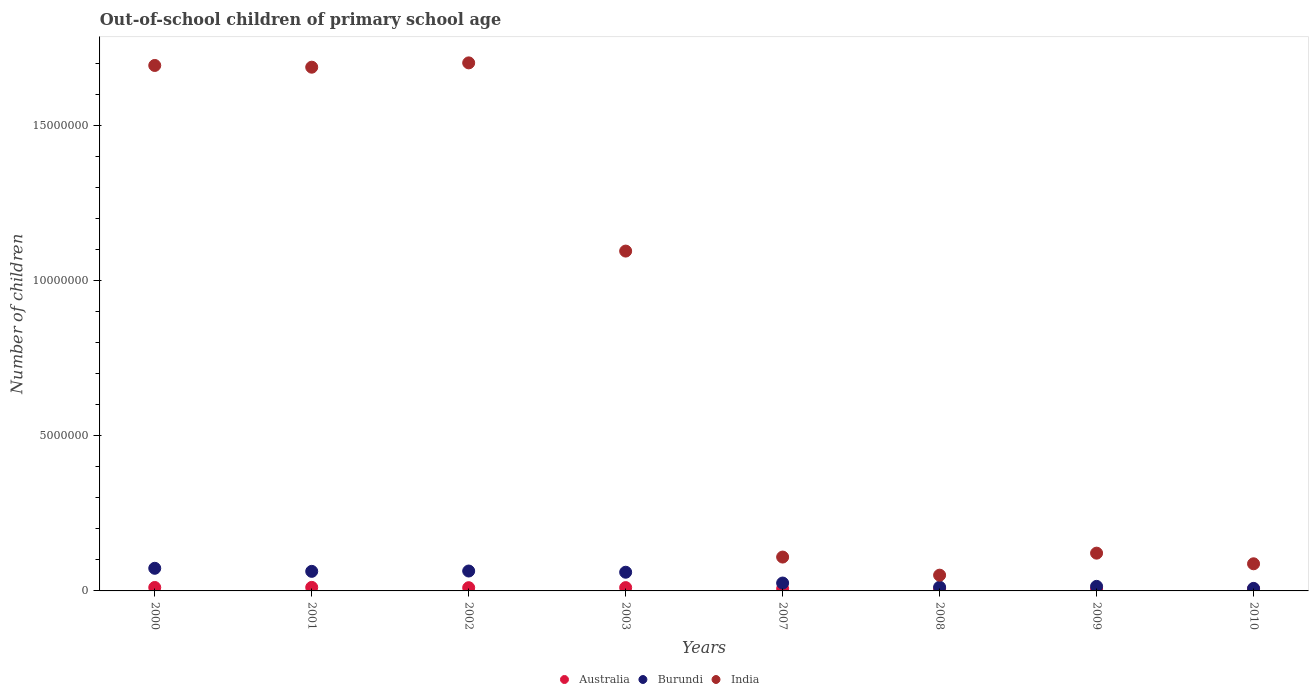What is the number of out-of-school children in Australia in 2001?
Ensure brevity in your answer.  1.14e+05. Across all years, what is the maximum number of out-of-school children in India?
Offer a very short reply. 1.70e+07. Across all years, what is the minimum number of out-of-school children in Burundi?
Ensure brevity in your answer.  8.12e+04. In which year was the number of out-of-school children in India maximum?
Offer a terse response. 2002. What is the total number of out-of-school children in Australia in the graph?
Your answer should be very brief. 7.07e+05. What is the difference between the number of out-of-school children in India in 2002 and that in 2007?
Provide a short and direct response. 1.59e+07. What is the difference between the number of out-of-school children in India in 2003 and the number of out-of-school children in Burundi in 2010?
Offer a very short reply. 1.09e+07. What is the average number of out-of-school children in India per year?
Ensure brevity in your answer.  8.19e+06. In the year 2000, what is the difference between the number of out-of-school children in Burundi and number of out-of-school children in Australia?
Offer a terse response. 6.19e+05. In how many years, is the number of out-of-school children in Australia greater than 1000000?
Keep it short and to the point. 0. What is the ratio of the number of out-of-school children in Burundi in 2002 to that in 2008?
Make the answer very short. 5.31. Is the number of out-of-school children in Burundi in 2000 less than that in 2002?
Make the answer very short. No. Is the difference between the number of out-of-school children in Burundi in 2009 and 2010 greater than the difference between the number of out-of-school children in Australia in 2009 and 2010?
Provide a short and direct response. Yes. What is the difference between the highest and the second highest number of out-of-school children in Burundi?
Keep it short and to the point. 8.79e+04. What is the difference between the highest and the lowest number of out-of-school children in India?
Your answer should be compact. 1.65e+07. Is the sum of the number of out-of-school children in Australia in 2003 and 2007 greater than the maximum number of out-of-school children in Burundi across all years?
Offer a very short reply. No. Is it the case that in every year, the sum of the number of out-of-school children in India and number of out-of-school children in Burundi  is greater than the number of out-of-school children in Australia?
Your response must be concise. Yes. What is the difference between two consecutive major ticks on the Y-axis?
Offer a terse response. 5.00e+06. Are the values on the major ticks of Y-axis written in scientific E-notation?
Give a very brief answer. No. Does the graph contain grids?
Ensure brevity in your answer.  No. What is the title of the graph?
Your answer should be compact. Out-of-school children of primary school age. Does "Philippines" appear as one of the legend labels in the graph?
Your answer should be very brief. No. What is the label or title of the Y-axis?
Your answer should be very brief. Number of children. What is the Number of children of Australia in 2000?
Offer a very short reply. 1.11e+05. What is the Number of children of Burundi in 2000?
Provide a short and direct response. 7.30e+05. What is the Number of children of India in 2000?
Keep it short and to the point. 1.69e+07. What is the Number of children of Australia in 2001?
Ensure brevity in your answer.  1.14e+05. What is the Number of children in Burundi in 2001?
Your response must be concise. 6.31e+05. What is the Number of children of India in 2001?
Your answer should be compact. 1.69e+07. What is the Number of children of Australia in 2002?
Keep it short and to the point. 1.04e+05. What is the Number of children of Burundi in 2002?
Offer a terse response. 6.42e+05. What is the Number of children in India in 2002?
Give a very brief answer. 1.70e+07. What is the Number of children in Australia in 2003?
Provide a succinct answer. 1.07e+05. What is the Number of children of Burundi in 2003?
Make the answer very short. 6.03e+05. What is the Number of children in India in 2003?
Provide a succinct answer. 1.10e+07. What is the Number of children of Australia in 2007?
Give a very brief answer. 7.13e+04. What is the Number of children of Burundi in 2007?
Offer a very short reply. 2.54e+05. What is the Number of children of India in 2007?
Provide a succinct answer. 1.09e+06. What is the Number of children in Australia in 2008?
Offer a very short reply. 6.86e+04. What is the Number of children in Burundi in 2008?
Your response must be concise. 1.21e+05. What is the Number of children of India in 2008?
Provide a short and direct response. 5.08e+05. What is the Number of children of Australia in 2009?
Ensure brevity in your answer.  6.49e+04. What is the Number of children of Burundi in 2009?
Offer a terse response. 1.47e+05. What is the Number of children in India in 2009?
Make the answer very short. 1.22e+06. What is the Number of children in Australia in 2010?
Your answer should be compact. 6.55e+04. What is the Number of children in Burundi in 2010?
Make the answer very short. 8.12e+04. What is the Number of children of India in 2010?
Keep it short and to the point. 8.75e+05. Across all years, what is the maximum Number of children of Australia?
Ensure brevity in your answer.  1.14e+05. Across all years, what is the maximum Number of children in Burundi?
Make the answer very short. 7.30e+05. Across all years, what is the maximum Number of children in India?
Make the answer very short. 1.70e+07. Across all years, what is the minimum Number of children in Australia?
Offer a very short reply. 6.49e+04. Across all years, what is the minimum Number of children of Burundi?
Ensure brevity in your answer.  8.12e+04. Across all years, what is the minimum Number of children of India?
Give a very brief answer. 5.08e+05. What is the total Number of children of Australia in the graph?
Your response must be concise. 7.07e+05. What is the total Number of children in Burundi in the graph?
Provide a succinct answer. 3.21e+06. What is the total Number of children in India in the graph?
Offer a very short reply. 6.55e+07. What is the difference between the Number of children in Australia in 2000 and that in 2001?
Your answer should be very brief. -3166. What is the difference between the Number of children in Burundi in 2000 and that in 2001?
Provide a short and direct response. 9.89e+04. What is the difference between the Number of children in India in 2000 and that in 2001?
Your answer should be compact. 5.58e+04. What is the difference between the Number of children of Australia in 2000 and that in 2002?
Offer a terse response. 6688. What is the difference between the Number of children of Burundi in 2000 and that in 2002?
Your answer should be compact. 8.79e+04. What is the difference between the Number of children in India in 2000 and that in 2002?
Your answer should be very brief. -8.34e+04. What is the difference between the Number of children in Australia in 2000 and that in 2003?
Offer a terse response. 4293. What is the difference between the Number of children in Burundi in 2000 and that in 2003?
Ensure brevity in your answer.  1.27e+05. What is the difference between the Number of children of India in 2000 and that in 2003?
Provide a short and direct response. 5.99e+06. What is the difference between the Number of children in Australia in 2000 and that in 2007?
Your answer should be very brief. 3.97e+04. What is the difference between the Number of children in Burundi in 2000 and that in 2007?
Offer a terse response. 4.76e+05. What is the difference between the Number of children in India in 2000 and that in 2007?
Give a very brief answer. 1.59e+07. What is the difference between the Number of children of Australia in 2000 and that in 2008?
Offer a very short reply. 4.24e+04. What is the difference between the Number of children of Burundi in 2000 and that in 2008?
Offer a terse response. 6.09e+05. What is the difference between the Number of children in India in 2000 and that in 2008?
Provide a succinct answer. 1.64e+07. What is the difference between the Number of children in Australia in 2000 and that in 2009?
Ensure brevity in your answer.  4.61e+04. What is the difference between the Number of children of Burundi in 2000 and that in 2009?
Give a very brief answer. 5.83e+05. What is the difference between the Number of children of India in 2000 and that in 2009?
Give a very brief answer. 1.57e+07. What is the difference between the Number of children in Australia in 2000 and that in 2010?
Your answer should be very brief. 4.55e+04. What is the difference between the Number of children of Burundi in 2000 and that in 2010?
Make the answer very short. 6.49e+05. What is the difference between the Number of children in India in 2000 and that in 2010?
Keep it short and to the point. 1.61e+07. What is the difference between the Number of children of Australia in 2001 and that in 2002?
Your answer should be very brief. 9854. What is the difference between the Number of children in Burundi in 2001 and that in 2002?
Keep it short and to the point. -1.10e+04. What is the difference between the Number of children of India in 2001 and that in 2002?
Ensure brevity in your answer.  -1.39e+05. What is the difference between the Number of children in Australia in 2001 and that in 2003?
Ensure brevity in your answer.  7459. What is the difference between the Number of children of Burundi in 2001 and that in 2003?
Keep it short and to the point. 2.81e+04. What is the difference between the Number of children in India in 2001 and that in 2003?
Make the answer very short. 5.93e+06. What is the difference between the Number of children in Australia in 2001 and that in 2007?
Keep it short and to the point. 4.29e+04. What is the difference between the Number of children of Burundi in 2001 and that in 2007?
Provide a short and direct response. 3.77e+05. What is the difference between the Number of children in India in 2001 and that in 2007?
Your answer should be compact. 1.58e+07. What is the difference between the Number of children in Australia in 2001 and that in 2008?
Offer a very short reply. 4.55e+04. What is the difference between the Number of children in Burundi in 2001 and that in 2008?
Make the answer very short. 5.10e+05. What is the difference between the Number of children of India in 2001 and that in 2008?
Your answer should be very brief. 1.64e+07. What is the difference between the Number of children of Australia in 2001 and that in 2009?
Provide a short and direct response. 4.93e+04. What is the difference between the Number of children in Burundi in 2001 and that in 2009?
Offer a very short reply. 4.84e+05. What is the difference between the Number of children of India in 2001 and that in 2009?
Offer a terse response. 1.57e+07. What is the difference between the Number of children of Australia in 2001 and that in 2010?
Your response must be concise. 4.87e+04. What is the difference between the Number of children in Burundi in 2001 and that in 2010?
Ensure brevity in your answer.  5.50e+05. What is the difference between the Number of children of India in 2001 and that in 2010?
Make the answer very short. 1.60e+07. What is the difference between the Number of children in Australia in 2002 and that in 2003?
Your response must be concise. -2395. What is the difference between the Number of children of Burundi in 2002 and that in 2003?
Your answer should be compact. 3.91e+04. What is the difference between the Number of children of India in 2002 and that in 2003?
Make the answer very short. 6.07e+06. What is the difference between the Number of children in Australia in 2002 and that in 2007?
Offer a very short reply. 3.30e+04. What is the difference between the Number of children of Burundi in 2002 and that in 2007?
Give a very brief answer. 3.88e+05. What is the difference between the Number of children of India in 2002 and that in 2007?
Provide a short and direct response. 1.59e+07. What is the difference between the Number of children in Australia in 2002 and that in 2008?
Keep it short and to the point. 3.57e+04. What is the difference between the Number of children of Burundi in 2002 and that in 2008?
Your answer should be compact. 5.21e+05. What is the difference between the Number of children of India in 2002 and that in 2008?
Offer a terse response. 1.65e+07. What is the difference between the Number of children of Australia in 2002 and that in 2009?
Ensure brevity in your answer.  3.94e+04. What is the difference between the Number of children in Burundi in 2002 and that in 2009?
Your answer should be very brief. 4.95e+05. What is the difference between the Number of children of India in 2002 and that in 2009?
Your answer should be very brief. 1.58e+07. What is the difference between the Number of children of Australia in 2002 and that in 2010?
Ensure brevity in your answer.  3.88e+04. What is the difference between the Number of children in Burundi in 2002 and that in 2010?
Your response must be concise. 5.61e+05. What is the difference between the Number of children of India in 2002 and that in 2010?
Provide a succinct answer. 1.62e+07. What is the difference between the Number of children in Australia in 2003 and that in 2007?
Ensure brevity in your answer.  3.54e+04. What is the difference between the Number of children of Burundi in 2003 and that in 2007?
Your response must be concise. 3.49e+05. What is the difference between the Number of children in India in 2003 and that in 2007?
Offer a terse response. 9.87e+06. What is the difference between the Number of children of Australia in 2003 and that in 2008?
Offer a terse response. 3.81e+04. What is the difference between the Number of children of Burundi in 2003 and that in 2008?
Ensure brevity in your answer.  4.82e+05. What is the difference between the Number of children in India in 2003 and that in 2008?
Provide a succinct answer. 1.05e+07. What is the difference between the Number of children of Australia in 2003 and that in 2009?
Provide a short and direct response. 4.18e+04. What is the difference between the Number of children of Burundi in 2003 and that in 2009?
Your answer should be very brief. 4.56e+05. What is the difference between the Number of children of India in 2003 and that in 2009?
Your answer should be very brief. 9.74e+06. What is the difference between the Number of children in Australia in 2003 and that in 2010?
Make the answer very short. 4.12e+04. What is the difference between the Number of children in Burundi in 2003 and that in 2010?
Your answer should be very brief. 5.22e+05. What is the difference between the Number of children of India in 2003 and that in 2010?
Offer a terse response. 1.01e+07. What is the difference between the Number of children in Australia in 2007 and that in 2008?
Provide a succinct answer. 2645. What is the difference between the Number of children of Burundi in 2007 and that in 2008?
Give a very brief answer. 1.33e+05. What is the difference between the Number of children of India in 2007 and that in 2008?
Your answer should be compact. 5.84e+05. What is the difference between the Number of children in Australia in 2007 and that in 2009?
Provide a short and direct response. 6358. What is the difference between the Number of children in Burundi in 2007 and that in 2009?
Provide a succinct answer. 1.07e+05. What is the difference between the Number of children in India in 2007 and that in 2009?
Your answer should be compact. -1.26e+05. What is the difference between the Number of children in Australia in 2007 and that in 2010?
Your response must be concise. 5799. What is the difference between the Number of children in Burundi in 2007 and that in 2010?
Provide a short and direct response. 1.73e+05. What is the difference between the Number of children of India in 2007 and that in 2010?
Give a very brief answer. 2.17e+05. What is the difference between the Number of children in Australia in 2008 and that in 2009?
Give a very brief answer. 3713. What is the difference between the Number of children of Burundi in 2008 and that in 2009?
Your answer should be compact. -2.60e+04. What is the difference between the Number of children in India in 2008 and that in 2009?
Keep it short and to the point. -7.10e+05. What is the difference between the Number of children of Australia in 2008 and that in 2010?
Make the answer very short. 3154. What is the difference between the Number of children of Burundi in 2008 and that in 2010?
Provide a succinct answer. 3.97e+04. What is the difference between the Number of children in India in 2008 and that in 2010?
Your response must be concise. -3.67e+05. What is the difference between the Number of children in Australia in 2009 and that in 2010?
Provide a succinct answer. -559. What is the difference between the Number of children in Burundi in 2009 and that in 2010?
Keep it short and to the point. 6.57e+04. What is the difference between the Number of children in India in 2009 and that in 2010?
Make the answer very short. 3.43e+05. What is the difference between the Number of children of Australia in 2000 and the Number of children of Burundi in 2001?
Your answer should be compact. -5.20e+05. What is the difference between the Number of children of Australia in 2000 and the Number of children of India in 2001?
Your answer should be very brief. -1.68e+07. What is the difference between the Number of children in Burundi in 2000 and the Number of children in India in 2001?
Your answer should be very brief. -1.62e+07. What is the difference between the Number of children of Australia in 2000 and the Number of children of Burundi in 2002?
Make the answer very short. -5.31e+05. What is the difference between the Number of children in Australia in 2000 and the Number of children in India in 2002?
Give a very brief answer. -1.69e+07. What is the difference between the Number of children of Burundi in 2000 and the Number of children of India in 2002?
Make the answer very short. -1.63e+07. What is the difference between the Number of children in Australia in 2000 and the Number of children in Burundi in 2003?
Your response must be concise. -4.92e+05. What is the difference between the Number of children in Australia in 2000 and the Number of children in India in 2003?
Offer a terse response. -1.08e+07. What is the difference between the Number of children in Burundi in 2000 and the Number of children in India in 2003?
Provide a short and direct response. -1.02e+07. What is the difference between the Number of children of Australia in 2000 and the Number of children of Burundi in 2007?
Your answer should be compact. -1.43e+05. What is the difference between the Number of children of Australia in 2000 and the Number of children of India in 2007?
Your answer should be compact. -9.81e+05. What is the difference between the Number of children of Burundi in 2000 and the Number of children of India in 2007?
Provide a short and direct response. -3.62e+05. What is the difference between the Number of children in Australia in 2000 and the Number of children in Burundi in 2008?
Provide a succinct answer. -9778. What is the difference between the Number of children in Australia in 2000 and the Number of children in India in 2008?
Offer a very short reply. -3.97e+05. What is the difference between the Number of children of Burundi in 2000 and the Number of children of India in 2008?
Keep it short and to the point. 2.22e+05. What is the difference between the Number of children of Australia in 2000 and the Number of children of Burundi in 2009?
Ensure brevity in your answer.  -3.58e+04. What is the difference between the Number of children in Australia in 2000 and the Number of children in India in 2009?
Your answer should be very brief. -1.11e+06. What is the difference between the Number of children in Burundi in 2000 and the Number of children in India in 2009?
Offer a terse response. -4.89e+05. What is the difference between the Number of children of Australia in 2000 and the Number of children of Burundi in 2010?
Ensure brevity in your answer.  2.99e+04. What is the difference between the Number of children of Australia in 2000 and the Number of children of India in 2010?
Make the answer very short. -7.64e+05. What is the difference between the Number of children in Burundi in 2000 and the Number of children in India in 2010?
Provide a succinct answer. -1.45e+05. What is the difference between the Number of children of Australia in 2001 and the Number of children of Burundi in 2002?
Provide a short and direct response. -5.28e+05. What is the difference between the Number of children of Australia in 2001 and the Number of children of India in 2002?
Your response must be concise. -1.69e+07. What is the difference between the Number of children in Burundi in 2001 and the Number of children in India in 2002?
Provide a short and direct response. -1.64e+07. What is the difference between the Number of children of Australia in 2001 and the Number of children of Burundi in 2003?
Offer a very short reply. -4.89e+05. What is the difference between the Number of children of Australia in 2001 and the Number of children of India in 2003?
Provide a succinct answer. -1.08e+07. What is the difference between the Number of children in Burundi in 2001 and the Number of children in India in 2003?
Provide a succinct answer. -1.03e+07. What is the difference between the Number of children of Australia in 2001 and the Number of children of Burundi in 2007?
Give a very brief answer. -1.40e+05. What is the difference between the Number of children in Australia in 2001 and the Number of children in India in 2007?
Your response must be concise. -9.78e+05. What is the difference between the Number of children in Burundi in 2001 and the Number of children in India in 2007?
Offer a very short reply. -4.61e+05. What is the difference between the Number of children in Australia in 2001 and the Number of children in Burundi in 2008?
Offer a terse response. -6612. What is the difference between the Number of children in Australia in 2001 and the Number of children in India in 2008?
Your answer should be very brief. -3.94e+05. What is the difference between the Number of children in Burundi in 2001 and the Number of children in India in 2008?
Ensure brevity in your answer.  1.23e+05. What is the difference between the Number of children in Australia in 2001 and the Number of children in Burundi in 2009?
Your answer should be compact. -3.26e+04. What is the difference between the Number of children in Australia in 2001 and the Number of children in India in 2009?
Offer a terse response. -1.10e+06. What is the difference between the Number of children in Burundi in 2001 and the Number of children in India in 2009?
Your answer should be very brief. -5.87e+05. What is the difference between the Number of children of Australia in 2001 and the Number of children of Burundi in 2010?
Your answer should be very brief. 3.30e+04. What is the difference between the Number of children of Australia in 2001 and the Number of children of India in 2010?
Make the answer very short. -7.61e+05. What is the difference between the Number of children of Burundi in 2001 and the Number of children of India in 2010?
Offer a terse response. -2.44e+05. What is the difference between the Number of children of Australia in 2002 and the Number of children of Burundi in 2003?
Ensure brevity in your answer.  -4.99e+05. What is the difference between the Number of children of Australia in 2002 and the Number of children of India in 2003?
Your answer should be very brief. -1.09e+07. What is the difference between the Number of children of Burundi in 2002 and the Number of children of India in 2003?
Keep it short and to the point. -1.03e+07. What is the difference between the Number of children in Australia in 2002 and the Number of children in Burundi in 2007?
Your response must be concise. -1.50e+05. What is the difference between the Number of children of Australia in 2002 and the Number of children of India in 2007?
Your response must be concise. -9.88e+05. What is the difference between the Number of children in Burundi in 2002 and the Number of children in India in 2007?
Your response must be concise. -4.50e+05. What is the difference between the Number of children in Australia in 2002 and the Number of children in Burundi in 2008?
Make the answer very short. -1.65e+04. What is the difference between the Number of children of Australia in 2002 and the Number of children of India in 2008?
Provide a short and direct response. -4.04e+05. What is the difference between the Number of children in Burundi in 2002 and the Number of children in India in 2008?
Make the answer very short. 1.34e+05. What is the difference between the Number of children in Australia in 2002 and the Number of children in Burundi in 2009?
Provide a succinct answer. -4.25e+04. What is the difference between the Number of children in Australia in 2002 and the Number of children in India in 2009?
Provide a short and direct response. -1.11e+06. What is the difference between the Number of children in Burundi in 2002 and the Number of children in India in 2009?
Make the answer very short. -5.76e+05. What is the difference between the Number of children of Australia in 2002 and the Number of children of Burundi in 2010?
Ensure brevity in your answer.  2.32e+04. What is the difference between the Number of children in Australia in 2002 and the Number of children in India in 2010?
Your answer should be compact. -7.71e+05. What is the difference between the Number of children in Burundi in 2002 and the Number of children in India in 2010?
Make the answer very short. -2.33e+05. What is the difference between the Number of children of Australia in 2003 and the Number of children of Burundi in 2007?
Your answer should be compact. -1.47e+05. What is the difference between the Number of children of Australia in 2003 and the Number of children of India in 2007?
Provide a short and direct response. -9.85e+05. What is the difference between the Number of children in Burundi in 2003 and the Number of children in India in 2007?
Your answer should be very brief. -4.89e+05. What is the difference between the Number of children of Australia in 2003 and the Number of children of Burundi in 2008?
Provide a short and direct response. -1.41e+04. What is the difference between the Number of children of Australia in 2003 and the Number of children of India in 2008?
Keep it short and to the point. -4.01e+05. What is the difference between the Number of children in Burundi in 2003 and the Number of children in India in 2008?
Your response must be concise. 9.48e+04. What is the difference between the Number of children in Australia in 2003 and the Number of children in Burundi in 2009?
Ensure brevity in your answer.  -4.01e+04. What is the difference between the Number of children in Australia in 2003 and the Number of children in India in 2009?
Ensure brevity in your answer.  -1.11e+06. What is the difference between the Number of children in Burundi in 2003 and the Number of children in India in 2009?
Make the answer very short. -6.16e+05. What is the difference between the Number of children of Australia in 2003 and the Number of children of Burundi in 2010?
Your answer should be very brief. 2.56e+04. What is the difference between the Number of children of Australia in 2003 and the Number of children of India in 2010?
Your response must be concise. -7.68e+05. What is the difference between the Number of children of Burundi in 2003 and the Number of children of India in 2010?
Your answer should be compact. -2.72e+05. What is the difference between the Number of children in Australia in 2007 and the Number of children in Burundi in 2008?
Ensure brevity in your answer.  -4.95e+04. What is the difference between the Number of children in Australia in 2007 and the Number of children in India in 2008?
Make the answer very short. -4.37e+05. What is the difference between the Number of children of Burundi in 2007 and the Number of children of India in 2008?
Provide a succinct answer. -2.54e+05. What is the difference between the Number of children in Australia in 2007 and the Number of children in Burundi in 2009?
Your answer should be compact. -7.55e+04. What is the difference between the Number of children in Australia in 2007 and the Number of children in India in 2009?
Your response must be concise. -1.15e+06. What is the difference between the Number of children in Burundi in 2007 and the Number of children in India in 2009?
Your response must be concise. -9.64e+05. What is the difference between the Number of children in Australia in 2007 and the Number of children in Burundi in 2010?
Give a very brief answer. -9858. What is the difference between the Number of children of Australia in 2007 and the Number of children of India in 2010?
Your response must be concise. -8.04e+05. What is the difference between the Number of children in Burundi in 2007 and the Number of children in India in 2010?
Your response must be concise. -6.21e+05. What is the difference between the Number of children of Australia in 2008 and the Number of children of Burundi in 2009?
Provide a succinct answer. -7.82e+04. What is the difference between the Number of children in Australia in 2008 and the Number of children in India in 2009?
Offer a terse response. -1.15e+06. What is the difference between the Number of children of Burundi in 2008 and the Number of children of India in 2009?
Keep it short and to the point. -1.10e+06. What is the difference between the Number of children of Australia in 2008 and the Number of children of Burundi in 2010?
Give a very brief answer. -1.25e+04. What is the difference between the Number of children of Australia in 2008 and the Number of children of India in 2010?
Your answer should be compact. -8.06e+05. What is the difference between the Number of children in Burundi in 2008 and the Number of children in India in 2010?
Your answer should be very brief. -7.54e+05. What is the difference between the Number of children of Australia in 2009 and the Number of children of Burundi in 2010?
Keep it short and to the point. -1.62e+04. What is the difference between the Number of children of Australia in 2009 and the Number of children of India in 2010?
Provide a short and direct response. -8.10e+05. What is the difference between the Number of children in Burundi in 2009 and the Number of children in India in 2010?
Give a very brief answer. -7.28e+05. What is the average Number of children in Australia per year?
Offer a terse response. 8.83e+04. What is the average Number of children of Burundi per year?
Provide a succinct answer. 4.01e+05. What is the average Number of children in India per year?
Offer a terse response. 8.19e+06. In the year 2000, what is the difference between the Number of children in Australia and Number of children in Burundi?
Ensure brevity in your answer.  -6.19e+05. In the year 2000, what is the difference between the Number of children of Australia and Number of children of India?
Your response must be concise. -1.68e+07. In the year 2000, what is the difference between the Number of children in Burundi and Number of children in India?
Keep it short and to the point. -1.62e+07. In the year 2001, what is the difference between the Number of children of Australia and Number of children of Burundi?
Your response must be concise. -5.17e+05. In the year 2001, what is the difference between the Number of children in Australia and Number of children in India?
Provide a short and direct response. -1.68e+07. In the year 2001, what is the difference between the Number of children of Burundi and Number of children of India?
Give a very brief answer. -1.63e+07. In the year 2002, what is the difference between the Number of children of Australia and Number of children of Burundi?
Your response must be concise. -5.38e+05. In the year 2002, what is the difference between the Number of children in Australia and Number of children in India?
Your response must be concise. -1.69e+07. In the year 2002, what is the difference between the Number of children of Burundi and Number of children of India?
Keep it short and to the point. -1.64e+07. In the year 2003, what is the difference between the Number of children of Australia and Number of children of Burundi?
Ensure brevity in your answer.  -4.96e+05. In the year 2003, what is the difference between the Number of children of Australia and Number of children of India?
Offer a terse response. -1.09e+07. In the year 2003, what is the difference between the Number of children of Burundi and Number of children of India?
Your answer should be compact. -1.04e+07. In the year 2007, what is the difference between the Number of children of Australia and Number of children of Burundi?
Your response must be concise. -1.83e+05. In the year 2007, what is the difference between the Number of children in Australia and Number of children in India?
Keep it short and to the point. -1.02e+06. In the year 2007, what is the difference between the Number of children in Burundi and Number of children in India?
Provide a succinct answer. -8.38e+05. In the year 2008, what is the difference between the Number of children in Australia and Number of children in Burundi?
Offer a terse response. -5.22e+04. In the year 2008, what is the difference between the Number of children in Australia and Number of children in India?
Your answer should be compact. -4.39e+05. In the year 2008, what is the difference between the Number of children in Burundi and Number of children in India?
Your answer should be compact. -3.87e+05. In the year 2009, what is the difference between the Number of children of Australia and Number of children of Burundi?
Keep it short and to the point. -8.19e+04. In the year 2009, what is the difference between the Number of children in Australia and Number of children in India?
Give a very brief answer. -1.15e+06. In the year 2009, what is the difference between the Number of children in Burundi and Number of children in India?
Your answer should be compact. -1.07e+06. In the year 2010, what is the difference between the Number of children in Australia and Number of children in Burundi?
Your response must be concise. -1.57e+04. In the year 2010, what is the difference between the Number of children of Australia and Number of children of India?
Give a very brief answer. -8.10e+05. In the year 2010, what is the difference between the Number of children in Burundi and Number of children in India?
Your response must be concise. -7.94e+05. What is the ratio of the Number of children in Australia in 2000 to that in 2001?
Your response must be concise. 0.97. What is the ratio of the Number of children in Burundi in 2000 to that in 2001?
Your answer should be very brief. 1.16. What is the ratio of the Number of children of Australia in 2000 to that in 2002?
Ensure brevity in your answer.  1.06. What is the ratio of the Number of children of Burundi in 2000 to that in 2002?
Give a very brief answer. 1.14. What is the ratio of the Number of children of India in 2000 to that in 2002?
Ensure brevity in your answer.  1. What is the ratio of the Number of children in Australia in 2000 to that in 2003?
Offer a very short reply. 1.04. What is the ratio of the Number of children in Burundi in 2000 to that in 2003?
Make the answer very short. 1.21. What is the ratio of the Number of children of India in 2000 to that in 2003?
Offer a very short reply. 1.55. What is the ratio of the Number of children in Australia in 2000 to that in 2007?
Keep it short and to the point. 1.56. What is the ratio of the Number of children in Burundi in 2000 to that in 2007?
Provide a short and direct response. 2.87. What is the ratio of the Number of children in India in 2000 to that in 2007?
Keep it short and to the point. 15.52. What is the ratio of the Number of children of Australia in 2000 to that in 2008?
Your answer should be compact. 1.62. What is the ratio of the Number of children in Burundi in 2000 to that in 2008?
Your answer should be very brief. 6.04. What is the ratio of the Number of children in India in 2000 to that in 2008?
Ensure brevity in your answer.  33.35. What is the ratio of the Number of children in Australia in 2000 to that in 2009?
Your answer should be compact. 1.71. What is the ratio of the Number of children in Burundi in 2000 to that in 2009?
Offer a terse response. 4.97. What is the ratio of the Number of children of India in 2000 to that in 2009?
Your response must be concise. 13.91. What is the ratio of the Number of children of Australia in 2000 to that in 2010?
Provide a short and direct response. 1.7. What is the ratio of the Number of children of Burundi in 2000 to that in 2010?
Ensure brevity in your answer.  8.99. What is the ratio of the Number of children in India in 2000 to that in 2010?
Your response must be concise. 19.37. What is the ratio of the Number of children of Australia in 2001 to that in 2002?
Provide a short and direct response. 1.09. What is the ratio of the Number of children in Burundi in 2001 to that in 2002?
Give a very brief answer. 0.98. What is the ratio of the Number of children of India in 2001 to that in 2002?
Your answer should be compact. 0.99. What is the ratio of the Number of children in Australia in 2001 to that in 2003?
Your response must be concise. 1.07. What is the ratio of the Number of children of Burundi in 2001 to that in 2003?
Provide a short and direct response. 1.05. What is the ratio of the Number of children of India in 2001 to that in 2003?
Your response must be concise. 1.54. What is the ratio of the Number of children of Australia in 2001 to that in 2007?
Ensure brevity in your answer.  1.6. What is the ratio of the Number of children in Burundi in 2001 to that in 2007?
Offer a terse response. 2.48. What is the ratio of the Number of children in India in 2001 to that in 2007?
Offer a terse response. 15.47. What is the ratio of the Number of children of Australia in 2001 to that in 2008?
Offer a very short reply. 1.66. What is the ratio of the Number of children of Burundi in 2001 to that in 2008?
Ensure brevity in your answer.  5.22. What is the ratio of the Number of children of India in 2001 to that in 2008?
Keep it short and to the point. 33.24. What is the ratio of the Number of children of Australia in 2001 to that in 2009?
Give a very brief answer. 1.76. What is the ratio of the Number of children of Burundi in 2001 to that in 2009?
Keep it short and to the point. 4.3. What is the ratio of the Number of children of India in 2001 to that in 2009?
Provide a succinct answer. 13.86. What is the ratio of the Number of children of Australia in 2001 to that in 2010?
Keep it short and to the point. 1.74. What is the ratio of the Number of children of Burundi in 2001 to that in 2010?
Ensure brevity in your answer.  7.78. What is the ratio of the Number of children in India in 2001 to that in 2010?
Make the answer very short. 19.3. What is the ratio of the Number of children of Australia in 2002 to that in 2003?
Give a very brief answer. 0.98. What is the ratio of the Number of children in Burundi in 2002 to that in 2003?
Ensure brevity in your answer.  1.06. What is the ratio of the Number of children of India in 2002 to that in 2003?
Your answer should be very brief. 1.55. What is the ratio of the Number of children of Australia in 2002 to that in 2007?
Keep it short and to the point. 1.46. What is the ratio of the Number of children in Burundi in 2002 to that in 2007?
Your answer should be compact. 2.53. What is the ratio of the Number of children in India in 2002 to that in 2007?
Your answer should be compact. 15.6. What is the ratio of the Number of children in Australia in 2002 to that in 2008?
Provide a short and direct response. 1.52. What is the ratio of the Number of children in Burundi in 2002 to that in 2008?
Offer a very short reply. 5.31. What is the ratio of the Number of children of India in 2002 to that in 2008?
Offer a terse response. 33.52. What is the ratio of the Number of children in Australia in 2002 to that in 2009?
Offer a terse response. 1.61. What is the ratio of the Number of children of Burundi in 2002 to that in 2009?
Provide a short and direct response. 4.37. What is the ratio of the Number of children of India in 2002 to that in 2009?
Offer a terse response. 13.98. What is the ratio of the Number of children in Australia in 2002 to that in 2010?
Your response must be concise. 1.59. What is the ratio of the Number of children of Burundi in 2002 to that in 2010?
Give a very brief answer. 7.91. What is the ratio of the Number of children of India in 2002 to that in 2010?
Ensure brevity in your answer.  19.46. What is the ratio of the Number of children in Australia in 2003 to that in 2007?
Offer a terse response. 1.5. What is the ratio of the Number of children in Burundi in 2003 to that in 2007?
Provide a succinct answer. 2.37. What is the ratio of the Number of children of India in 2003 to that in 2007?
Keep it short and to the point. 10.04. What is the ratio of the Number of children of Australia in 2003 to that in 2008?
Offer a very short reply. 1.55. What is the ratio of the Number of children of Burundi in 2003 to that in 2008?
Your response must be concise. 4.99. What is the ratio of the Number of children in India in 2003 to that in 2008?
Provide a succinct answer. 21.57. What is the ratio of the Number of children in Australia in 2003 to that in 2009?
Make the answer very short. 1.64. What is the ratio of the Number of children of Burundi in 2003 to that in 2009?
Keep it short and to the point. 4.11. What is the ratio of the Number of children of India in 2003 to that in 2009?
Offer a very short reply. 9. What is the ratio of the Number of children in Australia in 2003 to that in 2010?
Offer a terse response. 1.63. What is the ratio of the Number of children in Burundi in 2003 to that in 2010?
Your response must be concise. 7.43. What is the ratio of the Number of children in India in 2003 to that in 2010?
Make the answer very short. 12.53. What is the ratio of the Number of children of Australia in 2007 to that in 2008?
Provide a succinct answer. 1.04. What is the ratio of the Number of children of Burundi in 2007 to that in 2008?
Offer a terse response. 2.1. What is the ratio of the Number of children of India in 2007 to that in 2008?
Your answer should be compact. 2.15. What is the ratio of the Number of children in Australia in 2007 to that in 2009?
Your response must be concise. 1.1. What is the ratio of the Number of children of Burundi in 2007 to that in 2009?
Your answer should be compact. 1.73. What is the ratio of the Number of children of India in 2007 to that in 2009?
Make the answer very short. 0.9. What is the ratio of the Number of children in Australia in 2007 to that in 2010?
Give a very brief answer. 1.09. What is the ratio of the Number of children of Burundi in 2007 to that in 2010?
Make the answer very short. 3.13. What is the ratio of the Number of children of India in 2007 to that in 2010?
Keep it short and to the point. 1.25. What is the ratio of the Number of children of Australia in 2008 to that in 2009?
Make the answer very short. 1.06. What is the ratio of the Number of children of Burundi in 2008 to that in 2009?
Ensure brevity in your answer.  0.82. What is the ratio of the Number of children in India in 2008 to that in 2009?
Your answer should be very brief. 0.42. What is the ratio of the Number of children of Australia in 2008 to that in 2010?
Your answer should be compact. 1.05. What is the ratio of the Number of children of Burundi in 2008 to that in 2010?
Offer a very short reply. 1.49. What is the ratio of the Number of children in India in 2008 to that in 2010?
Make the answer very short. 0.58. What is the ratio of the Number of children of Australia in 2009 to that in 2010?
Offer a terse response. 0.99. What is the ratio of the Number of children of Burundi in 2009 to that in 2010?
Your response must be concise. 1.81. What is the ratio of the Number of children in India in 2009 to that in 2010?
Your response must be concise. 1.39. What is the difference between the highest and the second highest Number of children in Australia?
Offer a terse response. 3166. What is the difference between the highest and the second highest Number of children of Burundi?
Provide a succinct answer. 8.79e+04. What is the difference between the highest and the second highest Number of children in India?
Offer a terse response. 8.34e+04. What is the difference between the highest and the lowest Number of children of Australia?
Your answer should be compact. 4.93e+04. What is the difference between the highest and the lowest Number of children of Burundi?
Make the answer very short. 6.49e+05. What is the difference between the highest and the lowest Number of children in India?
Give a very brief answer. 1.65e+07. 